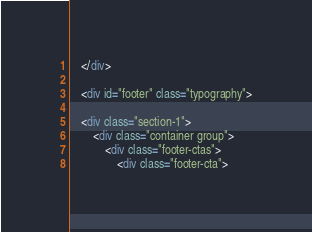<code> <loc_0><loc_0><loc_500><loc_500><_HTML_>



    </div>

    <div id="footer" class="typography">

    <div class="section-1">
        <div class="container group">
            <div class="footer-ctas">
                <div class="footer-cta"></code> 